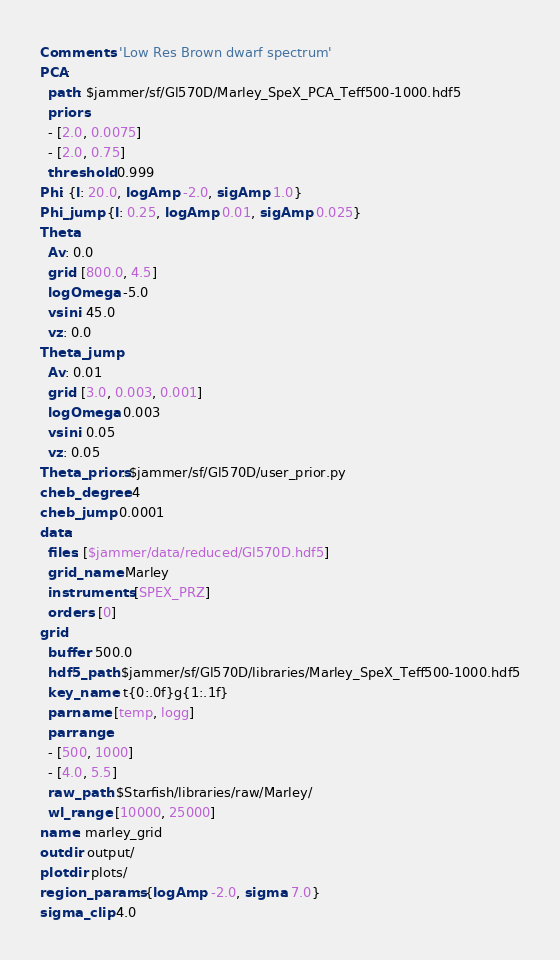Convert code to text. <code><loc_0><loc_0><loc_500><loc_500><_YAML_>Comments: 'Low Res Brown dwarf spectrum'
PCA:
  path: $jammer/sf/Gl570D/Marley_SpeX_PCA_Teff500-1000.hdf5
  priors:
  - [2.0, 0.0075]
  - [2.0, 0.75]
  threshold: 0.999
Phi: {l: 20.0, logAmp: -2.0, sigAmp: 1.0}
Phi_jump: {l: 0.25, logAmp: 0.01, sigAmp: 0.025}
Theta:
  Av: 0.0
  grid: [800.0, 4.5]
  logOmega: -5.0
  vsini: 45.0
  vz: 0.0
Theta_jump:
  Av: 0.01
  grid: [3.0, 0.003, 0.001]
  logOmega: 0.003
  vsini: 0.05
  vz: 0.05
Theta_priors: $jammer/sf/Gl570D/user_prior.py
cheb_degree: 4
cheb_jump: 0.0001
data:
  files: [$jammer/data/reduced/Gl570D.hdf5]
  grid_name: Marley
  instruments: [SPEX_PRZ]
  orders: [0]
grid:
  buffer: 500.0
  hdf5_path: $jammer/sf/Gl570D/libraries/Marley_SpeX_Teff500-1000.hdf5
  key_name: t{0:.0f}g{1:.1f}
  parname: [temp, logg]
  parrange:
  - [500, 1000]
  - [4.0, 5.5]
  raw_path: $Starfish/libraries/raw/Marley/
  wl_range: [10000, 25000]
name: marley_grid
outdir: output/
plotdir: plots/
region_params: {logAmp: -2.0, sigma: 7.0}
sigma_clip: 4.0
</code> 